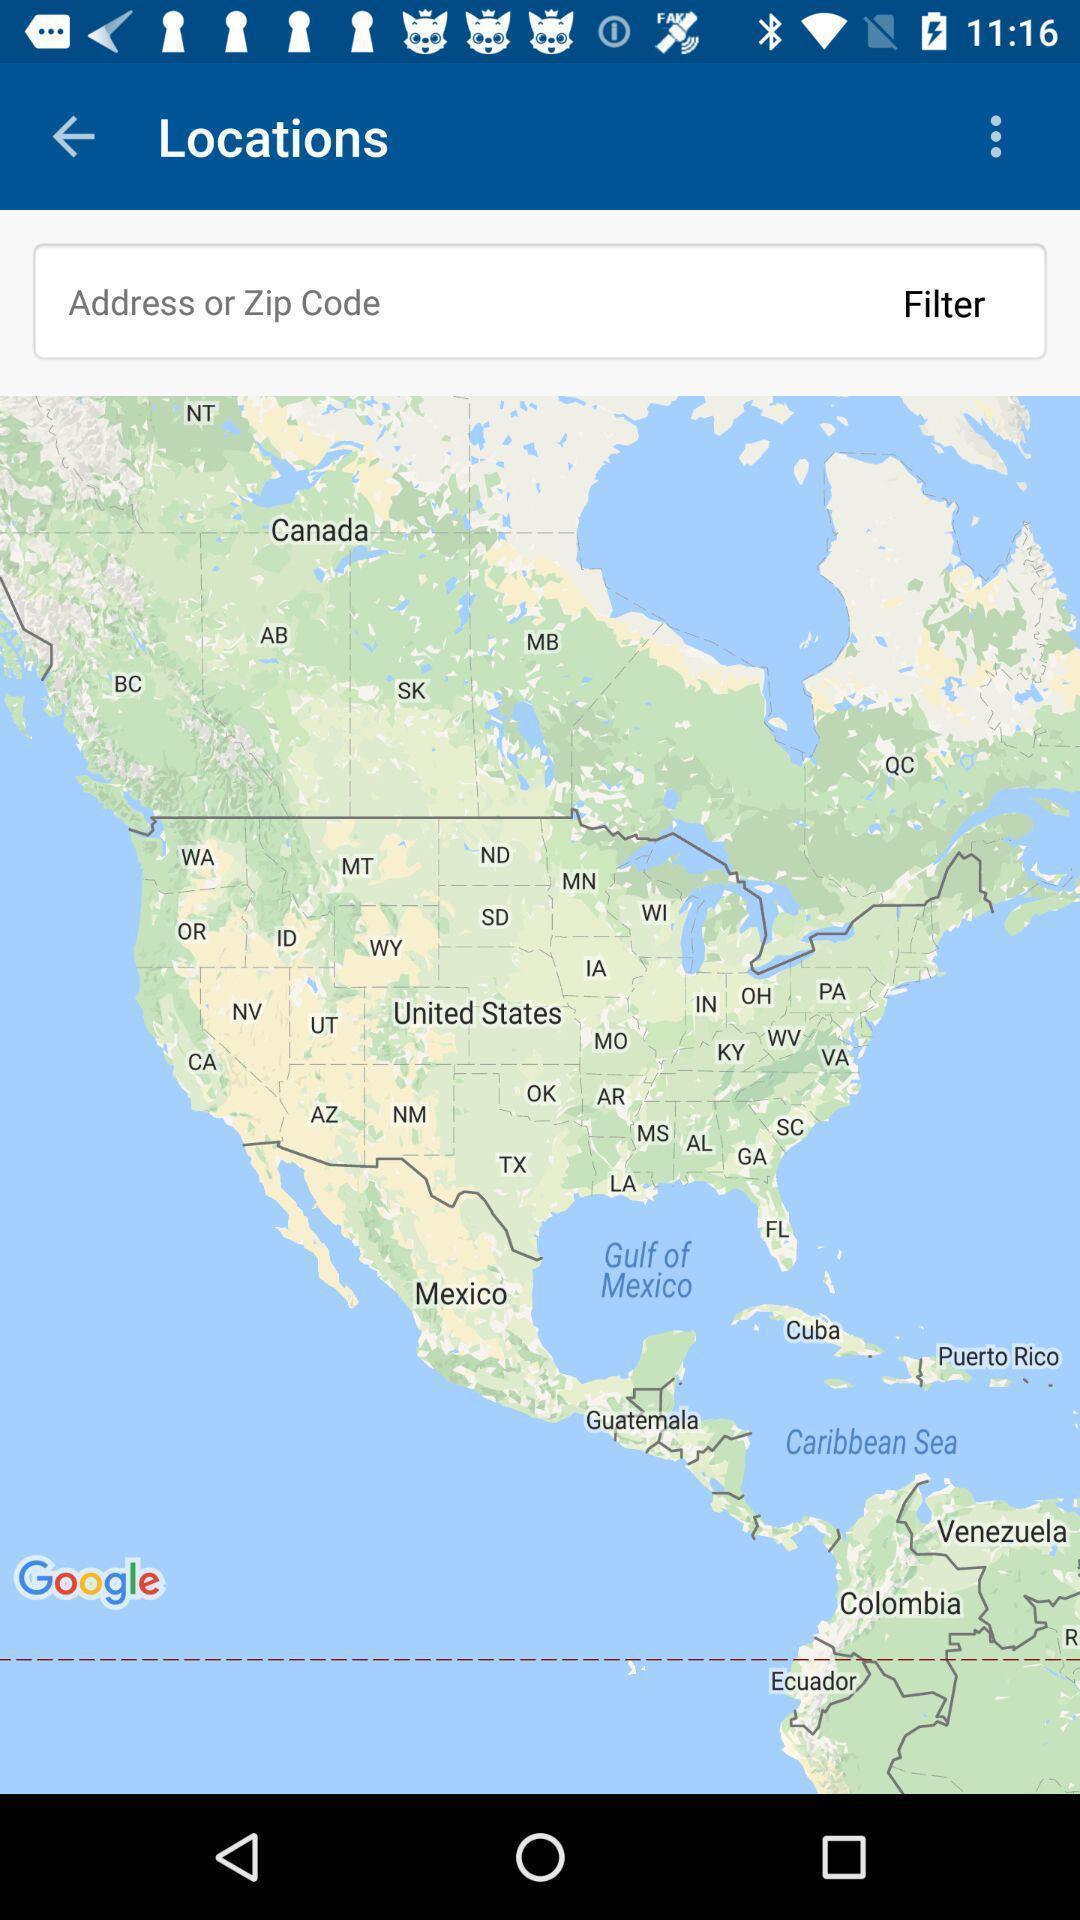Provide a textual representation of this image. Search page for searching a location on map. 